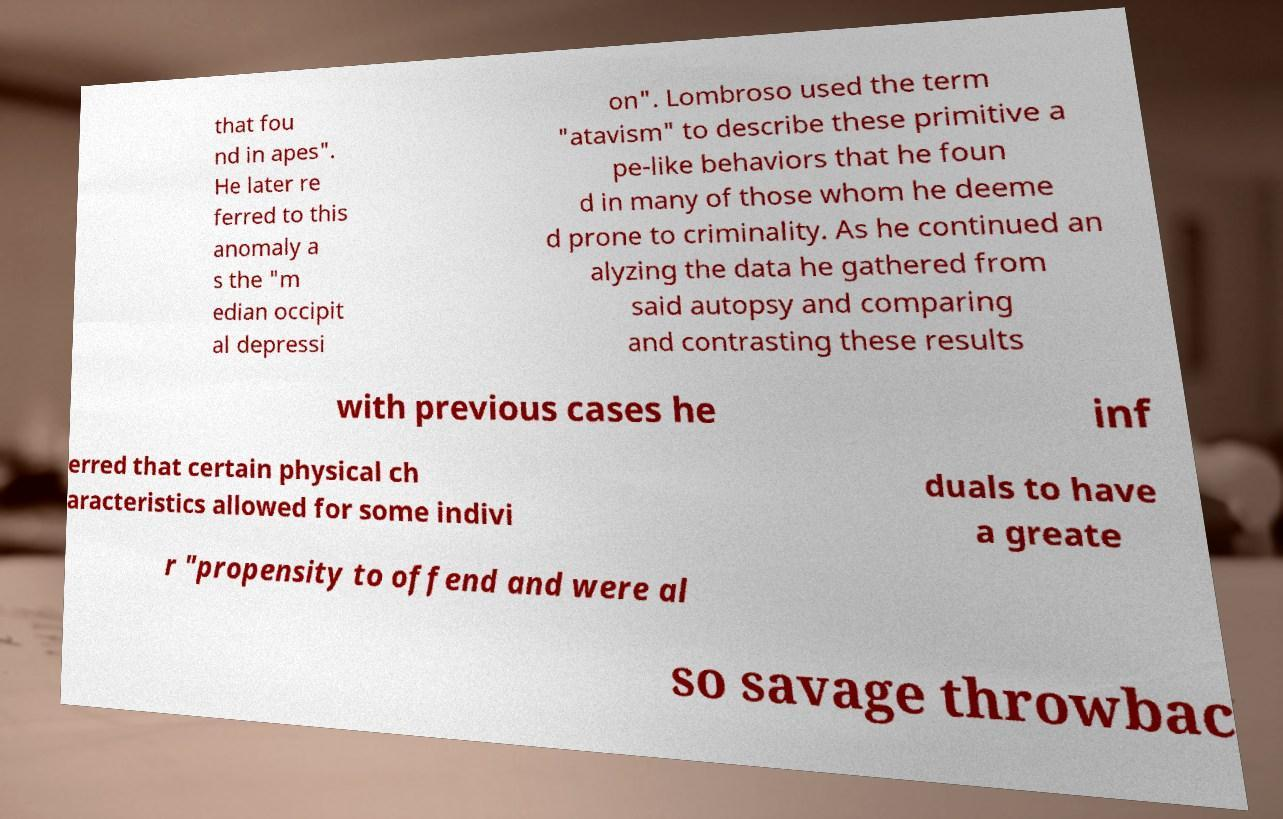Could you extract and type out the text from this image? that fou nd in apes". He later re ferred to this anomaly a s the "m edian occipit al depressi on". Lombroso used the term "atavism" to describe these primitive a pe-like behaviors that he foun d in many of those whom he deeme d prone to criminality. As he continued an alyzing the data he gathered from said autopsy and comparing and contrasting these results with previous cases he inf erred that certain physical ch aracteristics allowed for some indivi duals to have a greate r "propensity to offend and were al so savage throwbac 